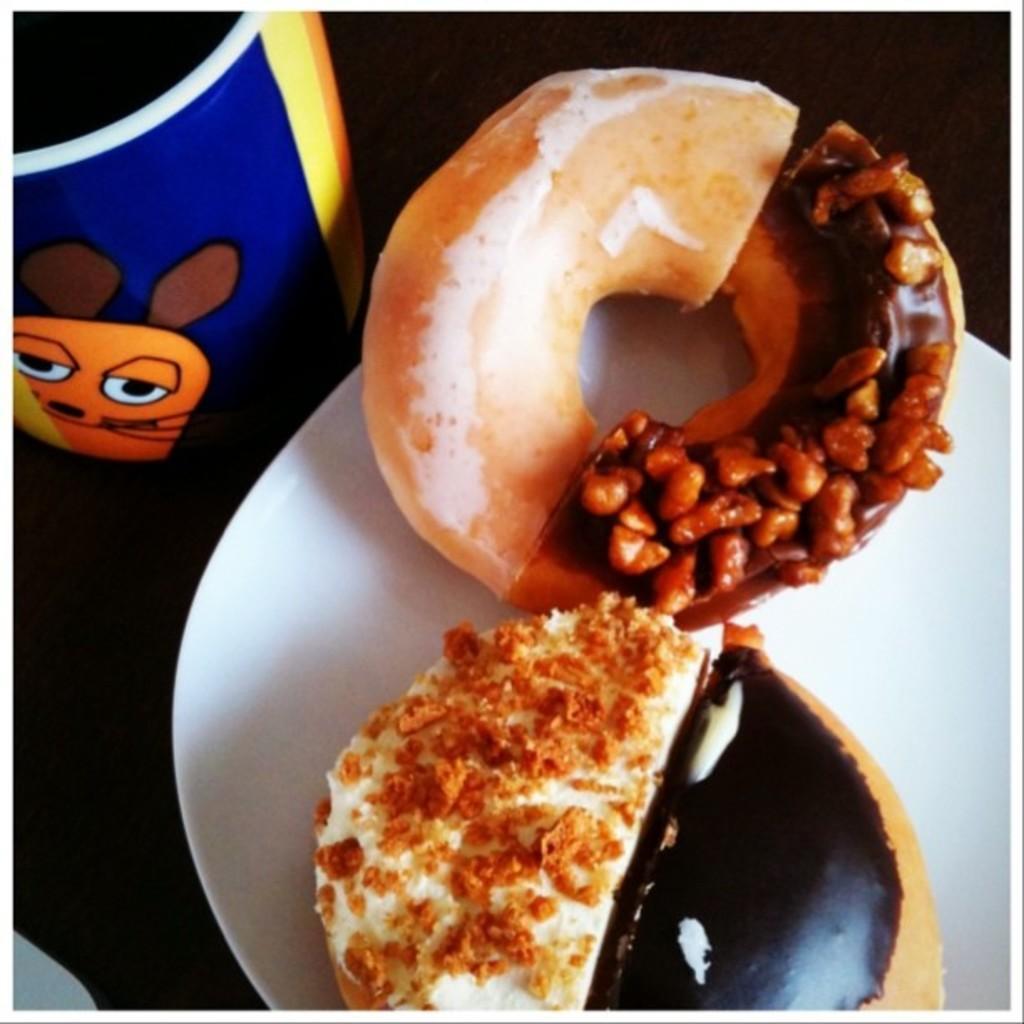Can you describe this image briefly? In this image we can see a doughnut on the plate, beside, there is a food item on it, there is a glass on the table. 